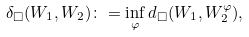<formula> <loc_0><loc_0><loc_500><loc_500>\delta _ { \square } ( W _ { 1 } , W _ { 2 } ) \colon = \inf _ { \varphi } d _ { \square } ( W _ { 1 } , W _ { 2 } ^ { \varphi } ) ,</formula> 